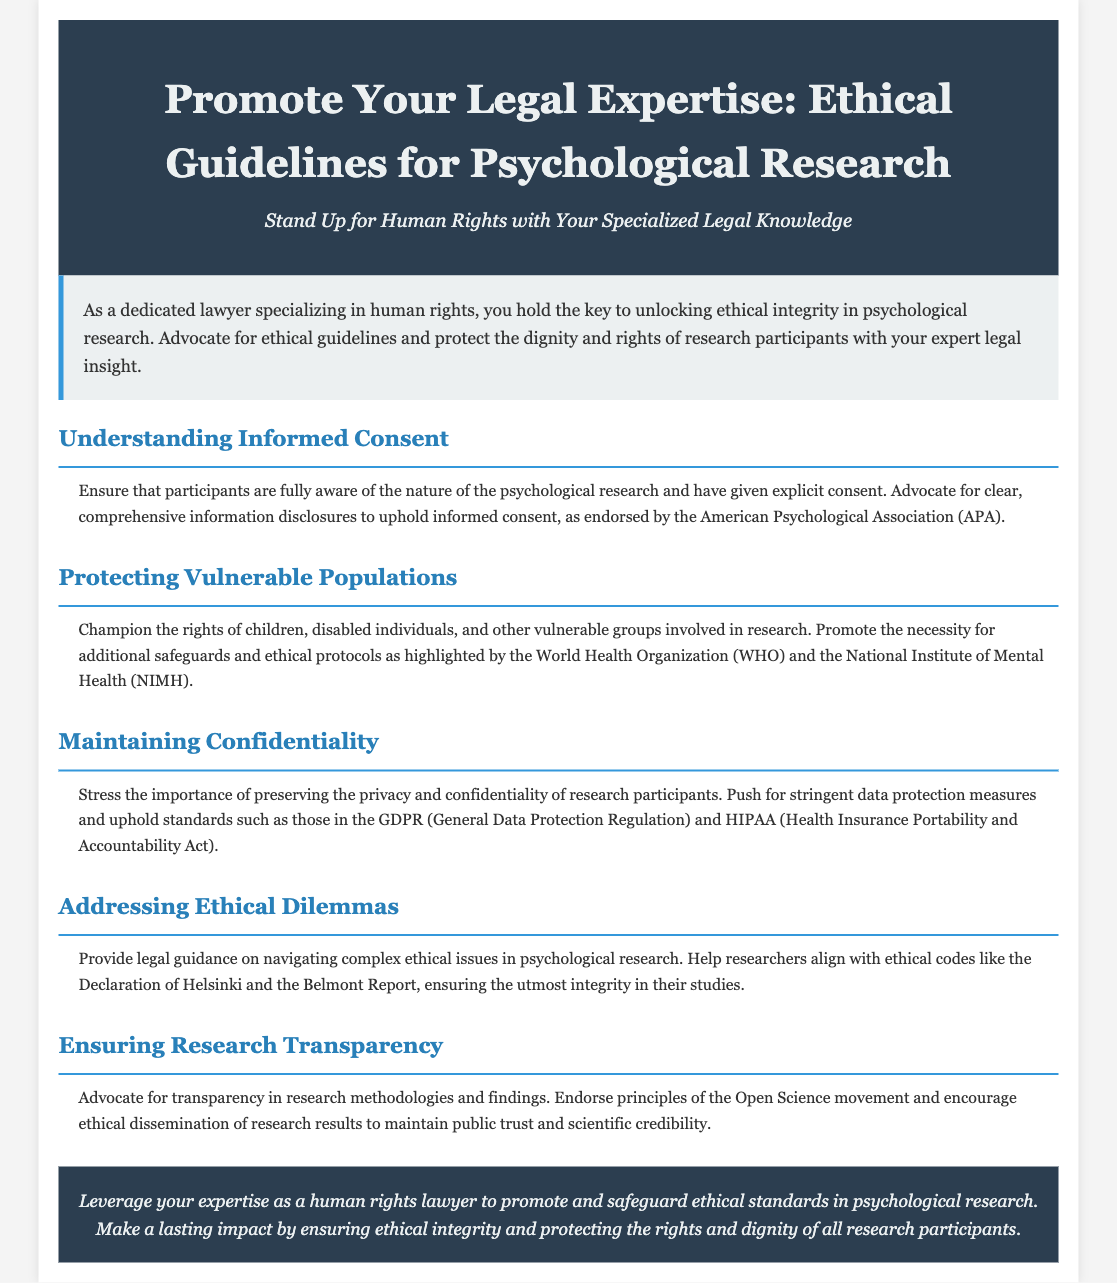What is the title of the document? The title of the document is mentioned in the header section prominently.
Answer: Promote Your Legal Expertise: Ethical Guidelines for Psychological Research Who should advocate for ethical guidelines in psychological research? The document highlights that dedicated lawyers specializing in human rights should advocate for ethical guidelines.
Answer: Lawyers specializing in human rights What is a key requirement related to informed consent? The document states that participants must give explicit consent and be fully aware of the research.
Answer: Explicit consent What is another name for the ethical protections required for vulnerable populations? The document mentions "additional safeguards" and "ethical protocols."
Answer: Additional safeguards Which regulations stress the importance of maintaining confidentiality? The document refers to GDPR and HIPAA as critical standards for data protection.
Answer: GDPR and HIPAA What ethical guidelines does the document suggest for addressing ethical dilemmas? It advises referencing the Declaration of Helsinki and the Belmont Report.
Answer: Declaration of Helsinki and the Belmont Report What movement does the document support for ensuring research transparency? The document endorses principles of the Open Science movement.
Answer: Open Science movement Who are mentioned as vulnerable groups that require protection in research? Children and disabled individuals are explicitly referenced in the document.
Answer: Children and disabled individuals 